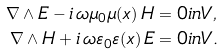<formula> <loc_0><loc_0><loc_500><loc_500>\nabla \wedge E - i \, \omega \mu _ { 0 } \mu ( x ) \, H & = 0 i n V , \\ \nabla \wedge H + i \, \omega \varepsilon _ { 0 } \varepsilon ( x ) \, E & = 0 i n V .</formula> 